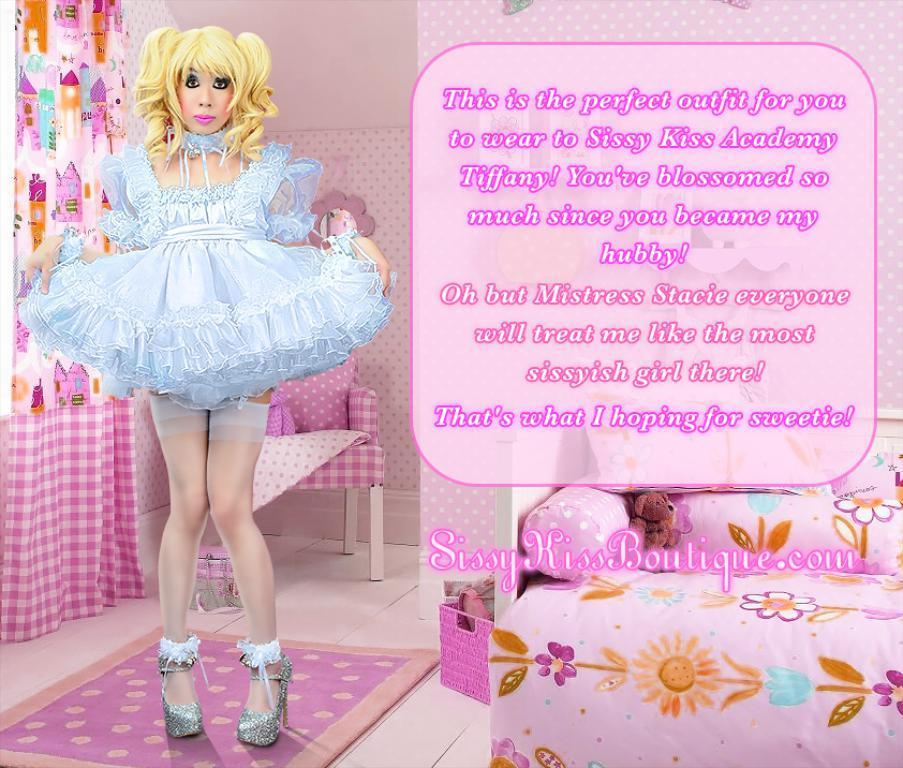Describe this image in one or two sentences. A woman is standing on a mat. Something written on this image. In this image we can see curtain, chair, box, basket, couch, teddy and pillows. Above the chair there is a cloth. In the basket there are things.  